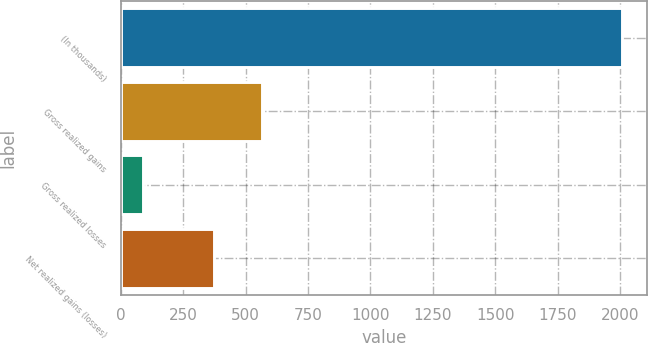Convert chart. <chart><loc_0><loc_0><loc_500><loc_500><bar_chart><fcel>(In thousands)<fcel>Gross realized gains<fcel>Gross realized losses<fcel>Net realized gains (losses)<nl><fcel>2008<fcel>567<fcel>88<fcel>375<nl></chart> 